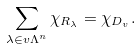<formula> <loc_0><loc_0><loc_500><loc_500>\sum _ { \lambda \in v \Lambda ^ { n } } \chi _ { R _ { \lambda } } = \chi _ { D _ { v } } .</formula> 